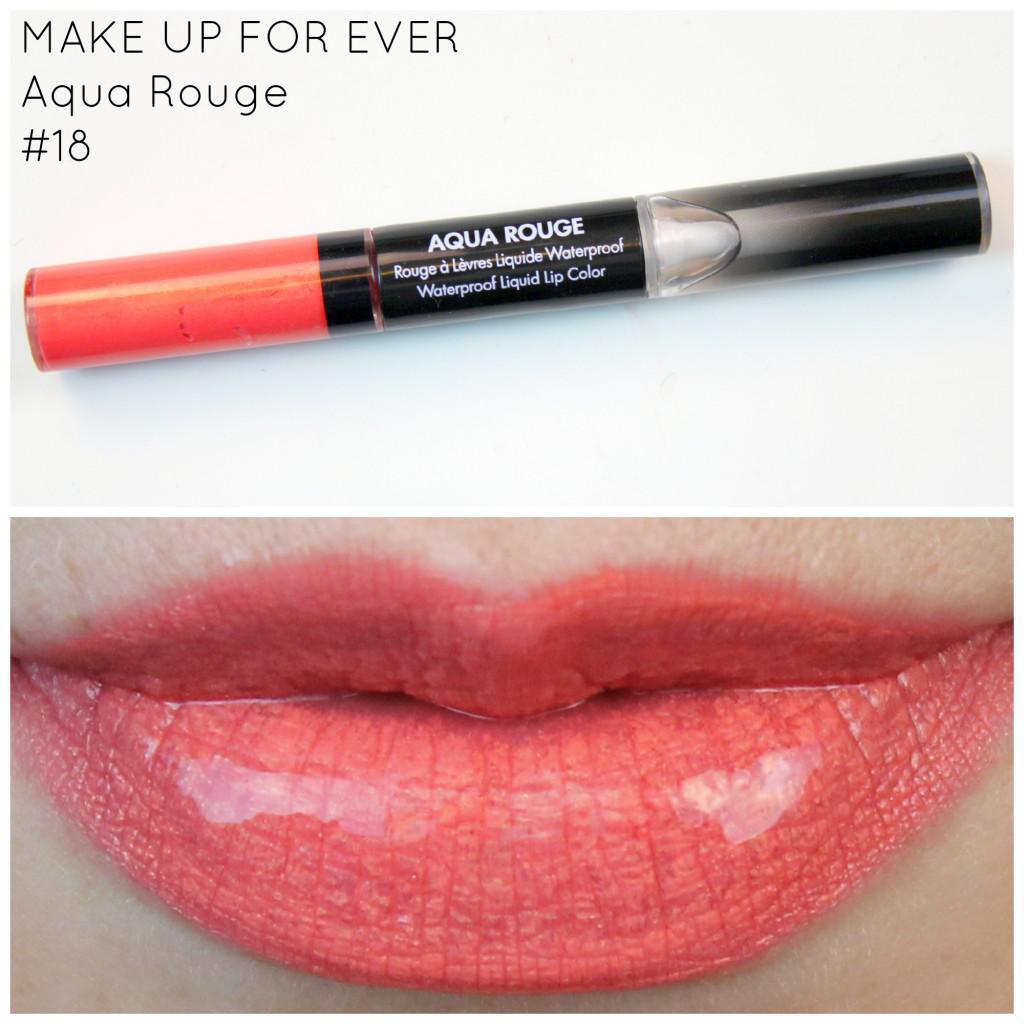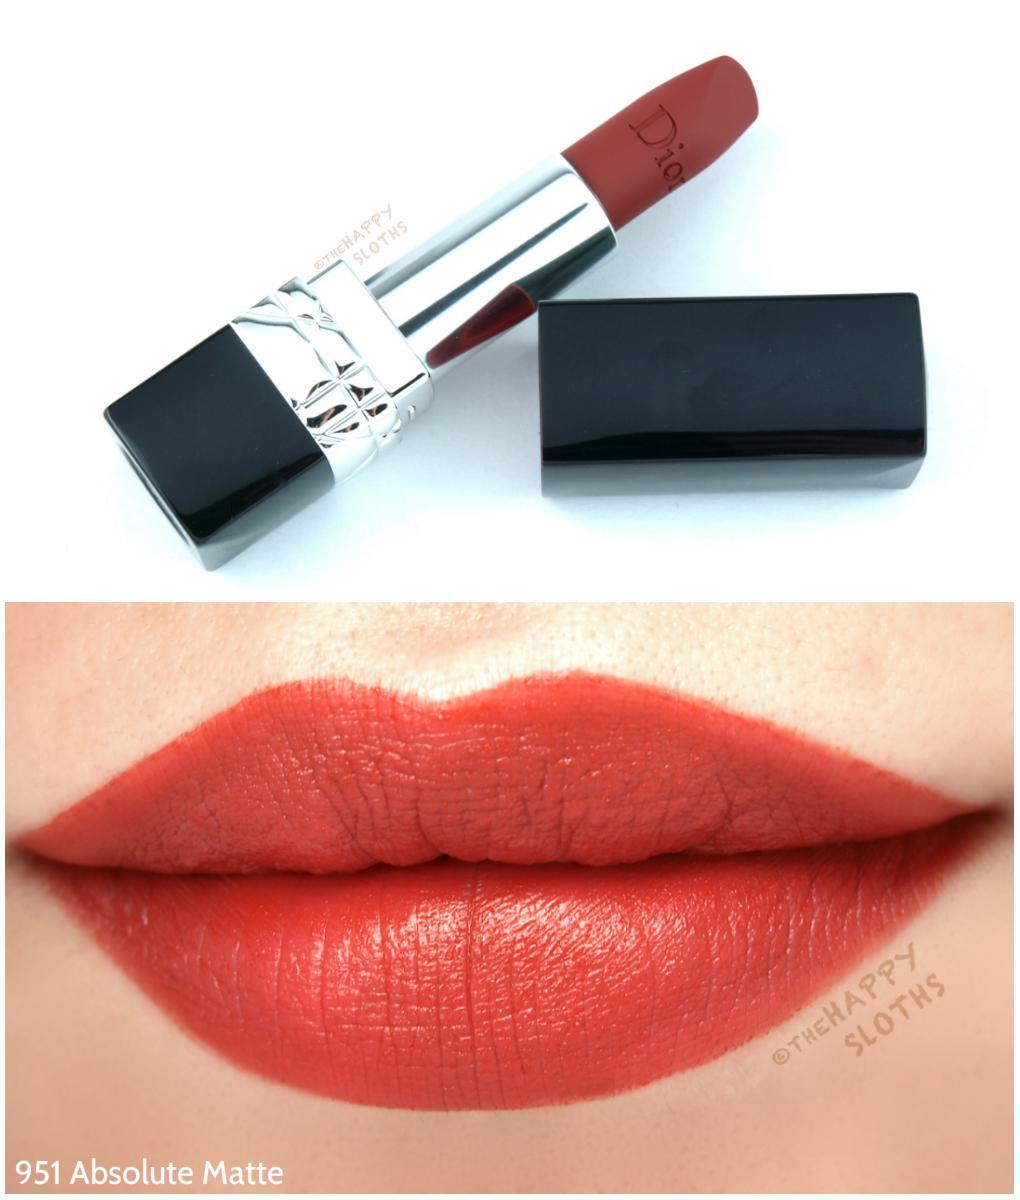The first image is the image on the left, the second image is the image on the right. Considering the images on both sides, is "The lip stick in the right image is uncapped." valid? Answer yes or no. Yes. The first image is the image on the left, the second image is the image on the right. Considering the images on both sides, is "The left image contains a lidded slender lip makeup over a pair of lips, while the right image shows an uncapped tube lipstick over a pair of lips." valid? Answer yes or no. Yes. 